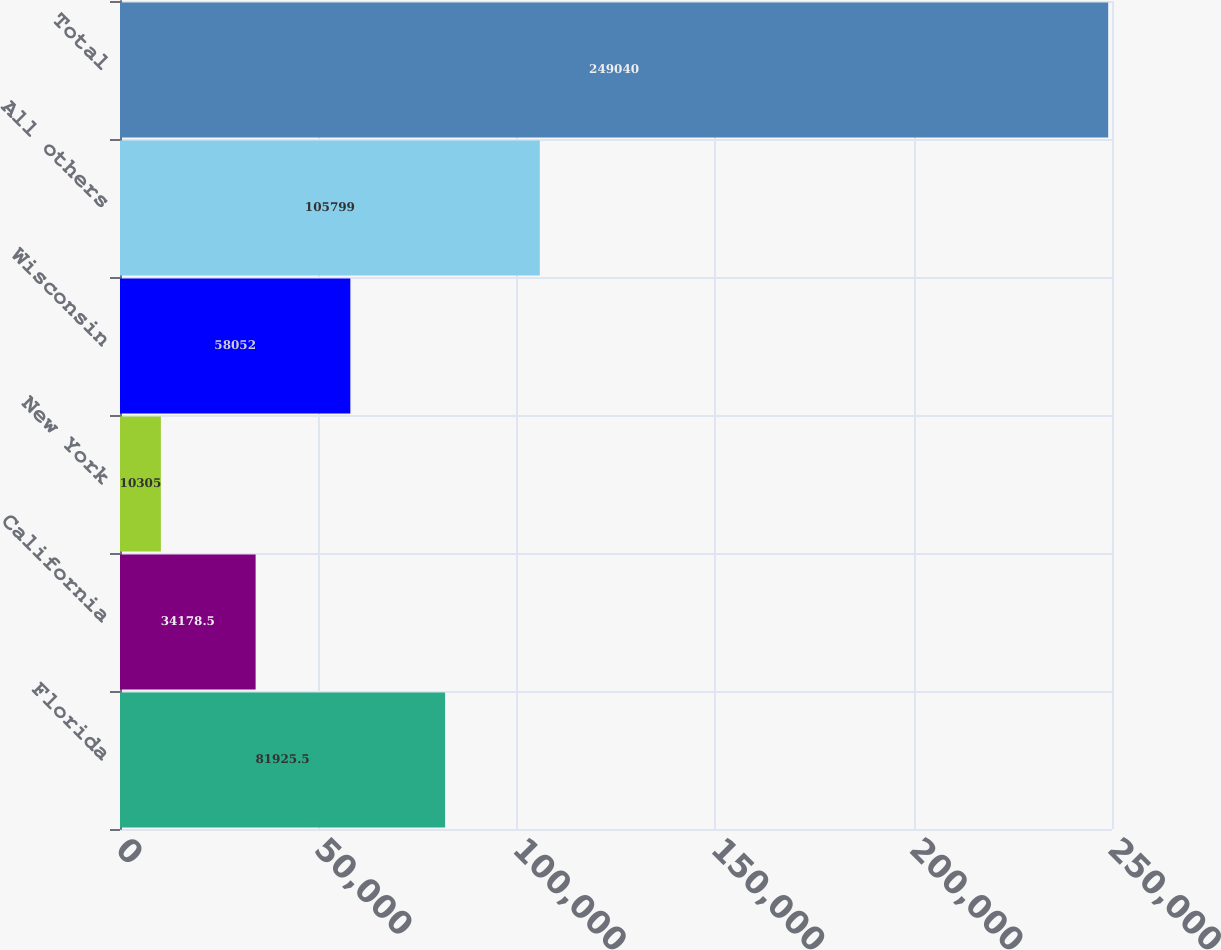Convert chart. <chart><loc_0><loc_0><loc_500><loc_500><bar_chart><fcel>Florida<fcel>California<fcel>New York<fcel>Wisconsin<fcel>All others<fcel>Total<nl><fcel>81925.5<fcel>34178.5<fcel>10305<fcel>58052<fcel>105799<fcel>249040<nl></chart> 